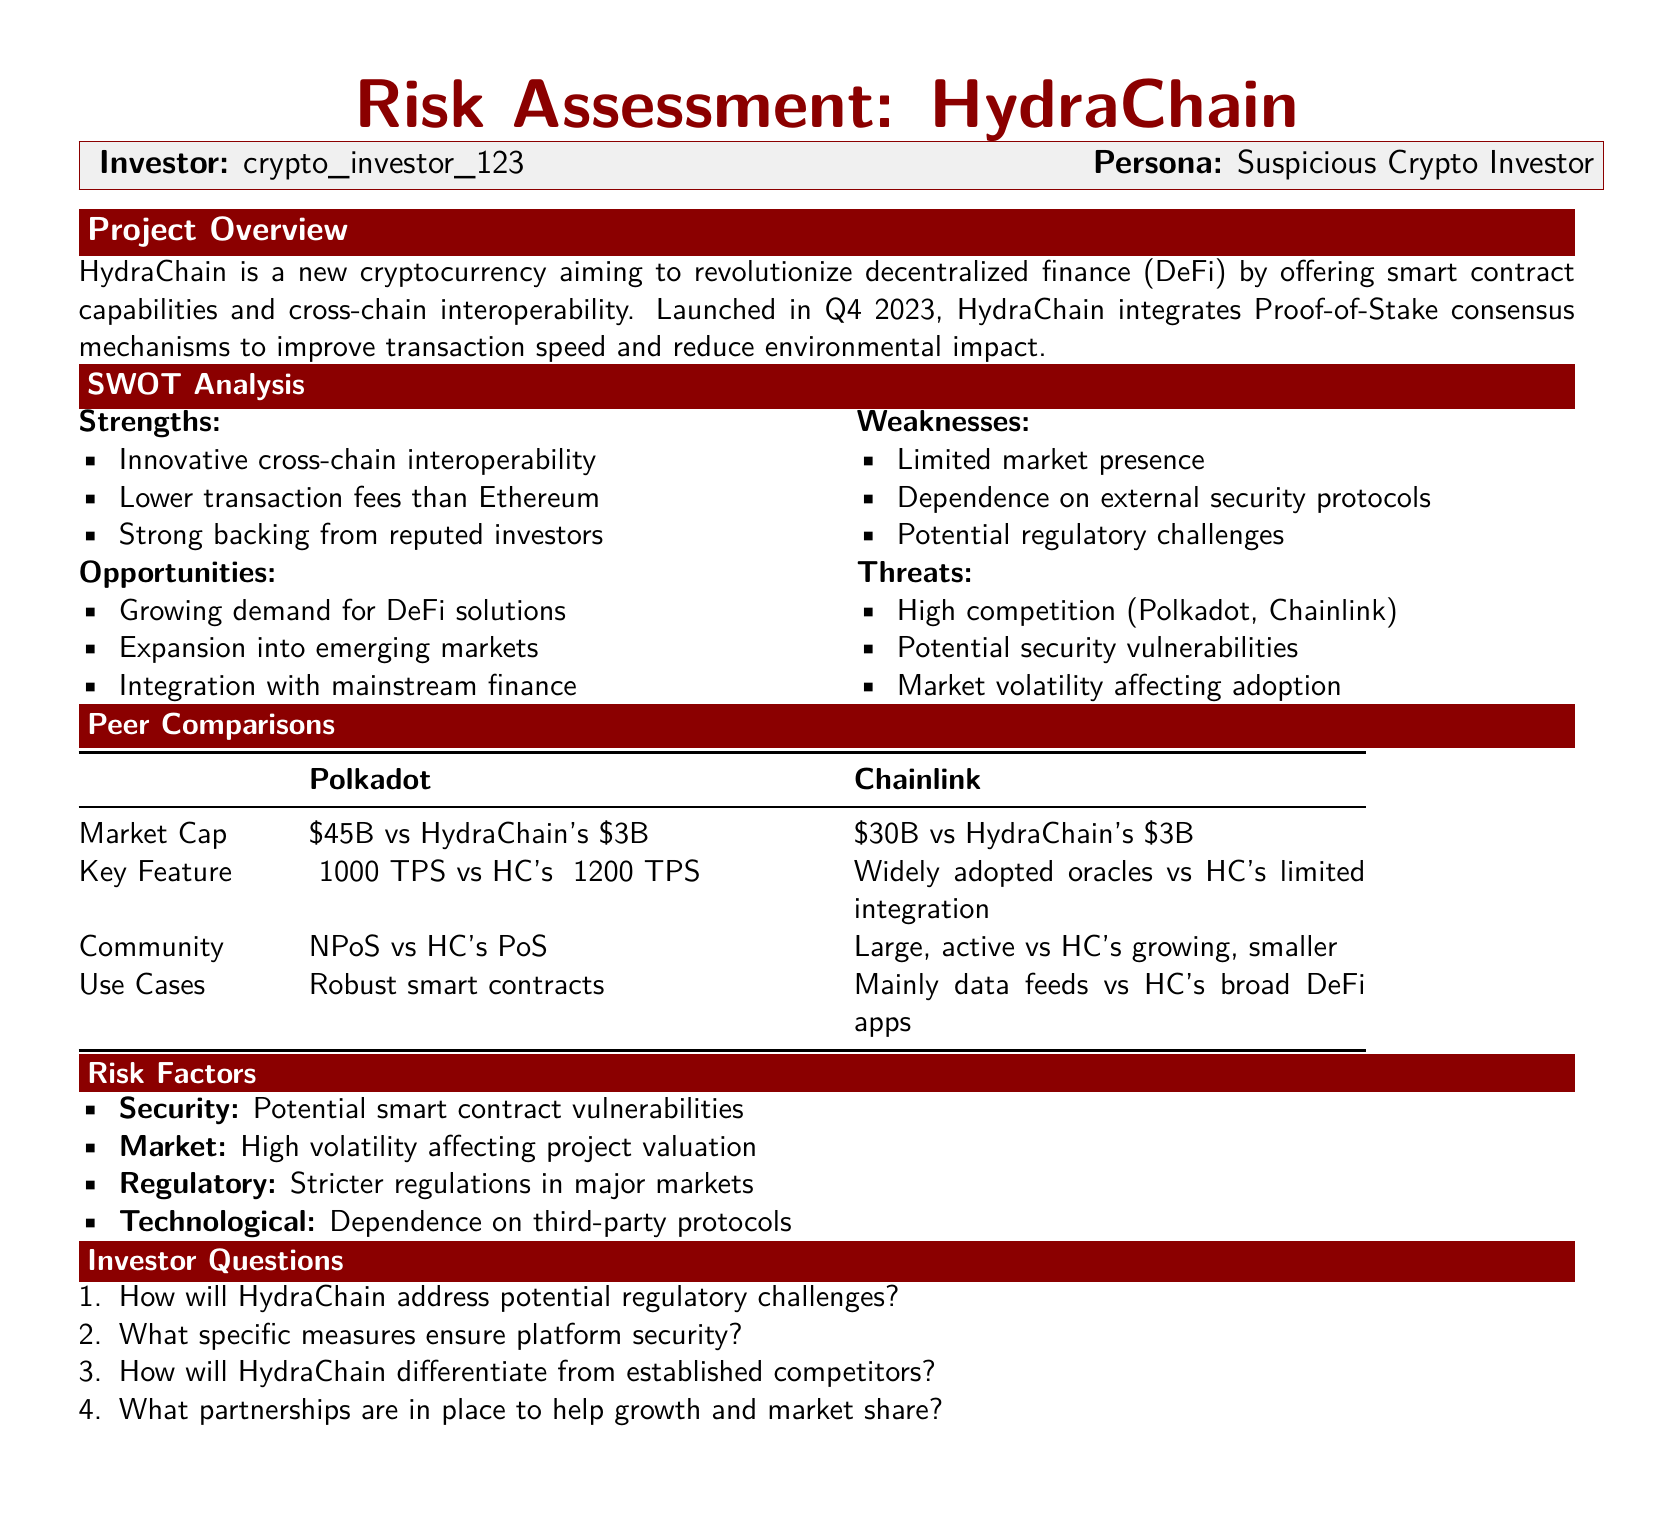what is the launch date of HydraChain? The document states that HydraChain was launched in Q4 2023.
Answer: Q4 2023 what is HydraChain's market cap? The document indicates that HydraChain's market cap is $3B.
Answer: $3B what consensus mechanism does HydraChain use? The document mentions that HydraChain uses Proof-of-Stake consensus mechanisms.
Answer: Proof-of-Stake which key feature does HydraChain have compared to Polkadot? The document compares their transaction speeds and states HydraChain has ~1200 TPS while Polkadot has ~1000 TPS.
Answer: ~1200 TPS what is one identified weakness of HydraChain? The document lists limited market presence as one of its weaknesses.
Answer: Limited market presence how does HydraChain's community size compare to Chainlink's? The document states that HydraChain has a growing, smaller community compared to Chainlink's large, active community.
Answer: Smaller community what are the regulatory risks mentioned for HydraChain? The document notes stricter regulations in major markets as a regulatory risk for HydraChain.
Answer: Stricter regulations what are some opportunities identified for HydraChain? The document includes growing demand for DeFi solutions as one of the opportunities.
Answer: Growing demand for DeFi solutions 